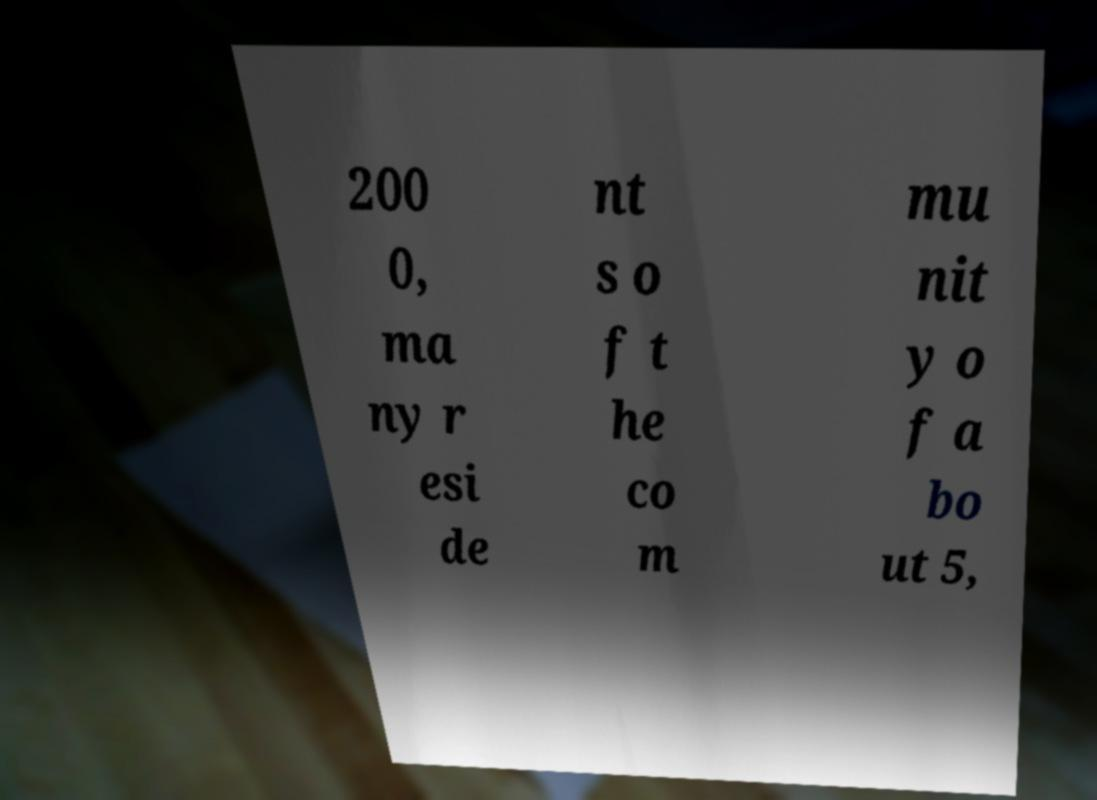Can you read and provide the text displayed in the image?This photo seems to have some interesting text. Can you extract and type it out for me? 200 0, ma ny r esi de nt s o f t he co m mu nit y o f a bo ut 5, 